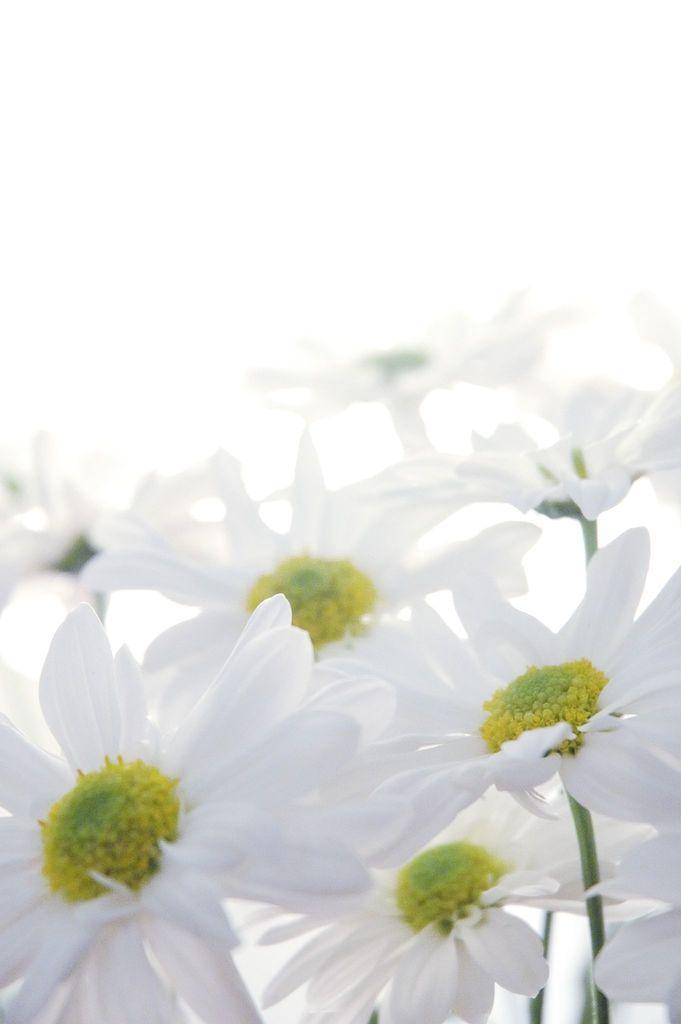Can you describe this image briefly? In this picture I can see there are a bunch of flowers attached to the stems and the backdrop of the image surface is white. 